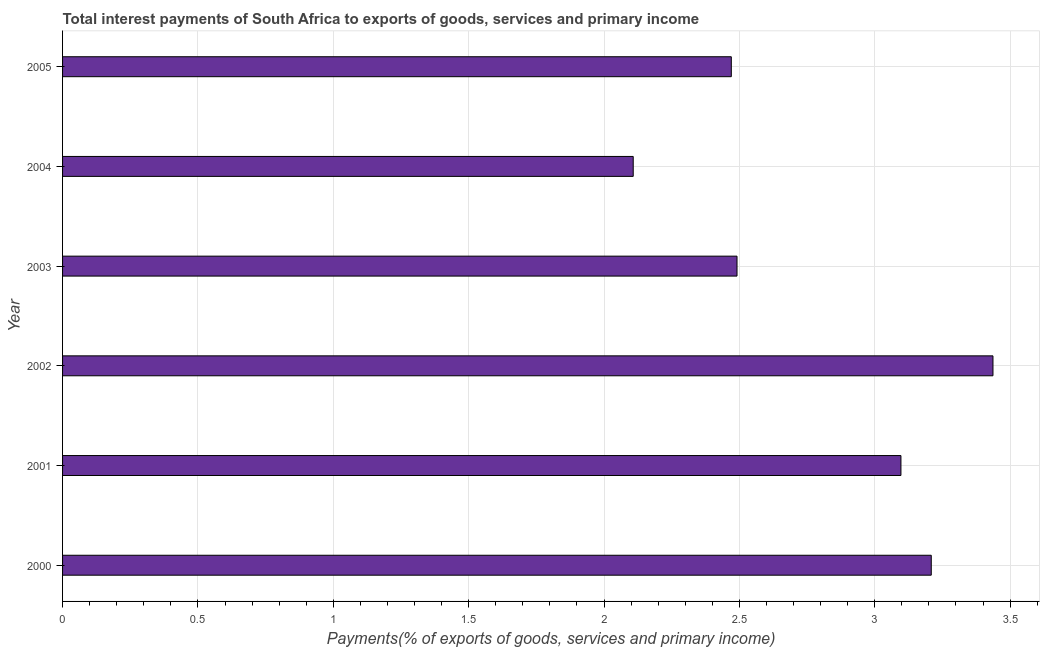Does the graph contain any zero values?
Provide a succinct answer. No. What is the title of the graph?
Ensure brevity in your answer.  Total interest payments of South Africa to exports of goods, services and primary income. What is the label or title of the X-axis?
Ensure brevity in your answer.  Payments(% of exports of goods, services and primary income). What is the label or title of the Y-axis?
Offer a terse response. Year. What is the total interest payments on external debt in 2003?
Provide a succinct answer. 2.49. Across all years, what is the maximum total interest payments on external debt?
Provide a short and direct response. 3.44. Across all years, what is the minimum total interest payments on external debt?
Give a very brief answer. 2.11. In which year was the total interest payments on external debt minimum?
Give a very brief answer. 2004. What is the sum of the total interest payments on external debt?
Provide a succinct answer. 16.81. What is the difference between the total interest payments on external debt in 2002 and 2003?
Provide a short and direct response. 0.94. What is the average total interest payments on external debt per year?
Offer a very short reply. 2.8. What is the median total interest payments on external debt?
Your answer should be compact. 2.79. In how many years, is the total interest payments on external debt greater than 1.3 %?
Provide a succinct answer. 6. Do a majority of the years between 2000 and 2001 (inclusive) have total interest payments on external debt greater than 1.2 %?
Your answer should be compact. Yes. What is the ratio of the total interest payments on external debt in 2002 to that in 2005?
Ensure brevity in your answer.  1.39. Is the total interest payments on external debt in 2000 less than that in 2003?
Make the answer very short. No. What is the difference between the highest and the second highest total interest payments on external debt?
Make the answer very short. 0.23. What is the difference between the highest and the lowest total interest payments on external debt?
Provide a succinct answer. 1.33. How many bars are there?
Keep it short and to the point. 6. How many years are there in the graph?
Your response must be concise. 6. What is the difference between two consecutive major ticks on the X-axis?
Give a very brief answer. 0.5. What is the Payments(% of exports of goods, services and primary income) of 2000?
Give a very brief answer. 3.21. What is the Payments(% of exports of goods, services and primary income) of 2001?
Give a very brief answer. 3.1. What is the Payments(% of exports of goods, services and primary income) of 2002?
Your answer should be very brief. 3.44. What is the Payments(% of exports of goods, services and primary income) of 2003?
Offer a terse response. 2.49. What is the Payments(% of exports of goods, services and primary income) in 2004?
Provide a short and direct response. 2.11. What is the Payments(% of exports of goods, services and primary income) of 2005?
Keep it short and to the point. 2.47. What is the difference between the Payments(% of exports of goods, services and primary income) in 2000 and 2001?
Ensure brevity in your answer.  0.11. What is the difference between the Payments(% of exports of goods, services and primary income) in 2000 and 2002?
Your answer should be compact. -0.23. What is the difference between the Payments(% of exports of goods, services and primary income) in 2000 and 2003?
Keep it short and to the point. 0.72. What is the difference between the Payments(% of exports of goods, services and primary income) in 2000 and 2004?
Provide a short and direct response. 1.1. What is the difference between the Payments(% of exports of goods, services and primary income) in 2000 and 2005?
Give a very brief answer. 0.74. What is the difference between the Payments(% of exports of goods, services and primary income) in 2001 and 2002?
Provide a succinct answer. -0.34. What is the difference between the Payments(% of exports of goods, services and primary income) in 2001 and 2003?
Keep it short and to the point. 0.61. What is the difference between the Payments(% of exports of goods, services and primary income) in 2001 and 2004?
Provide a succinct answer. 0.99. What is the difference between the Payments(% of exports of goods, services and primary income) in 2001 and 2005?
Provide a short and direct response. 0.63. What is the difference between the Payments(% of exports of goods, services and primary income) in 2002 and 2003?
Your response must be concise. 0.95. What is the difference between the Payments(% of exports of goods, services and primary income) in 2002 and 2004?
Your response must be concise. 1.33. What is the difference between the Payments(% of exports of goods, services and primary income) in 2002 and 2005?
Keep it short and to the point. 0.97. What is the difference between the Payments(% of exports of goods, services and primary income) in 2003 and 2004?
Offer a very short reply. 0.38. What is the difference between the Payments(% of exports of goods, services and primary income) in 2003 and 2005?
Provide a succinct answer. 0.02. What is the difference between the Payments(% of exports of goods, services and primary income) in 2004 and 2005?
Provide a short and direct response. -0.36. What is the ratio of the Payments(% of exports of goods, services and primary income) in 2000 to that in 2001?
Make the answer very short. 1.04. What is the ratio of the Payments(% of exports of goods, services and primary income) in 2000 to that in 2002?
Offer a very short reply. 0.93. What is the ratio of the Payments(% of exports of goods, services and primary income) in 2000 to that in 2003?
Make the answer very short. 1.29. What is the ratio of the Payments(% of exports of goods, services and primary income) in 2000 to that in 2004?
Offer a very short reply. 1.52. What is the ratio of the Payments(% of exports of goods, services and primary income) in 2000 to that in 2005?
Provide a short and direct response. 1.3. What is the ratio of the Payments(% of exports of goods, services and primary income) in 2001 to that in 2002?
Make the answer very short. 0.9. What is the ratio of the Payments(% of exports of goods, services and primary income) in 2001 to that in 2003?
Your answer should be compact. 1.24. What is the ratio of the Payments(% of exports of goods, services and primary income) in 2001 to that in 2004?
Ensure brevity in your answer.  1.47. What is the ratio of the Payments(% of exports of goods, services and primary income) in 2001 to that in 2005?
Offer a very short reply. 1.25. What is the ratio of the Payments(% of exports of goods, services and primary income) in 2002 to that in 2003?
Make the answer very short. 1.38. What is the ratio of the Payments(% of exports of goods, services and primary income) in 2002 to that in 2004?
Your answer should be very brief. 1.63. What is the ratio of the Payments(% of exports of goods, services and primary income) in 2002 to that in 2005?
Make the answer very short. 1.39. What is the ratio of the Payments(% of exports of goods, services and primary income) in 2003 to that in 2004?
Make the answer very short. 1.18. What is the ratio of the Payments(% of exports of goods, services and primary income) in 2004 to that in 2005?
Ensure brevity in your answer.  0.85. 